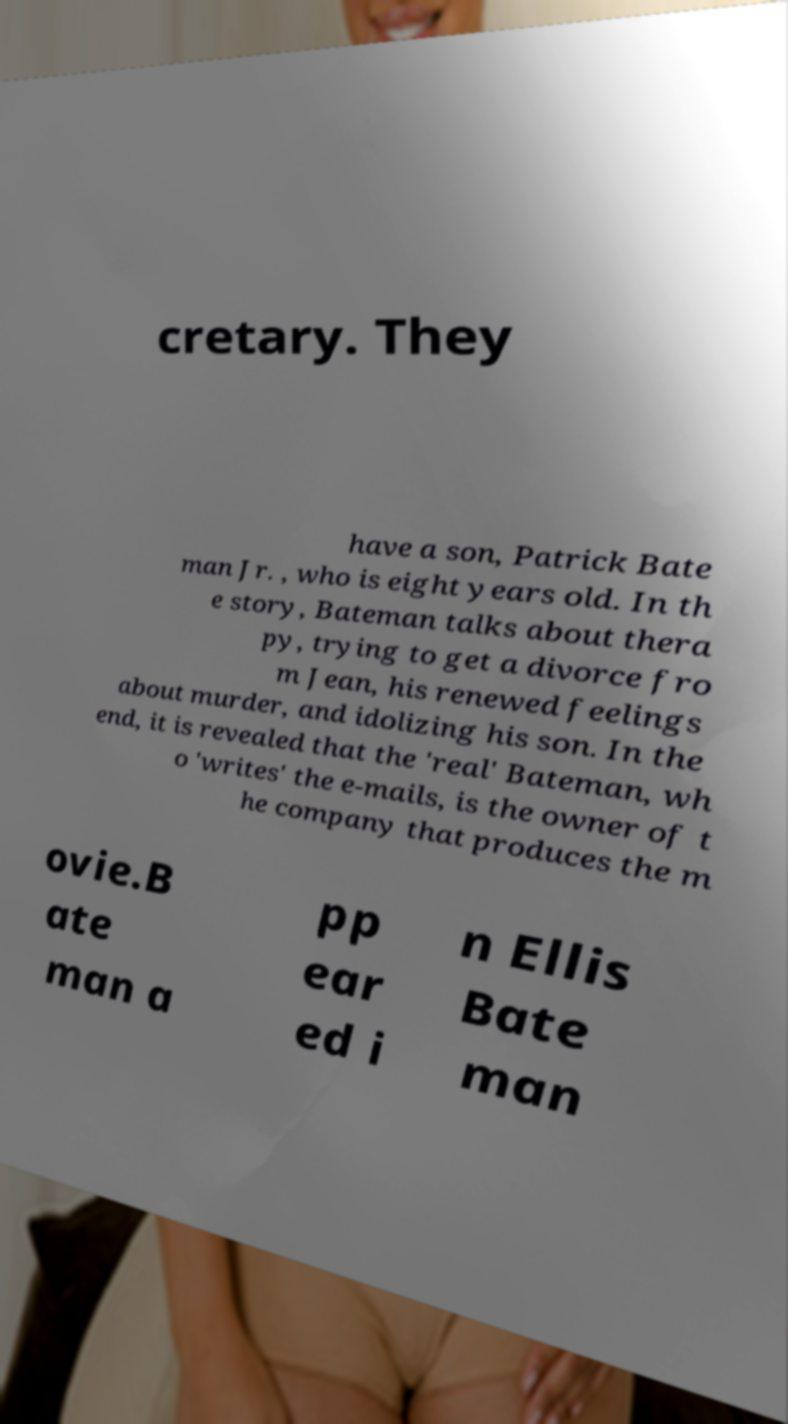What messages or text are displayed in this image? I need them in a readable, typed format. cretary. They have a son, Patrick Bate man Jr. , who is eight years old. In th e story, Bateman talks about thera py, trying to get a divorce fro m Jean, his renewed feelings about murder, and idolizing his son. In the end, it is revealed that the 'real' Bateman, wh o 'writes' the e-mails, is the owner of t he company that produces the m ovie.B ate man a pp ear ed i n Ellis Bate man 